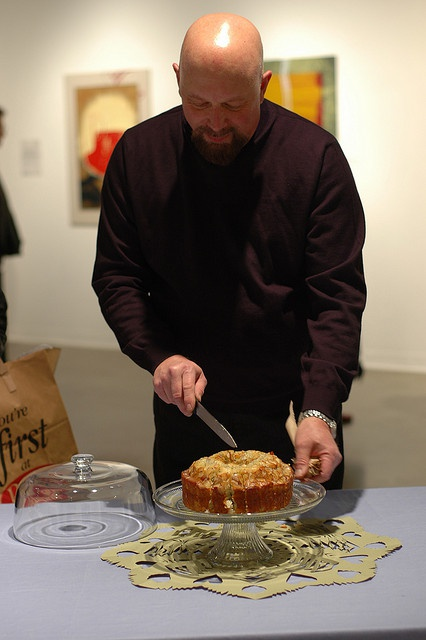Describe the objects in this image and their specific colors. I can see people in darkgray, black, maroon, brown, and salmon tones, dining table in darkgray, gray, and lightgray tones, cake in darkgray, maroon, brown, and tan tones, and knife in darkgray, gray, maroon, and black tones in this image. 